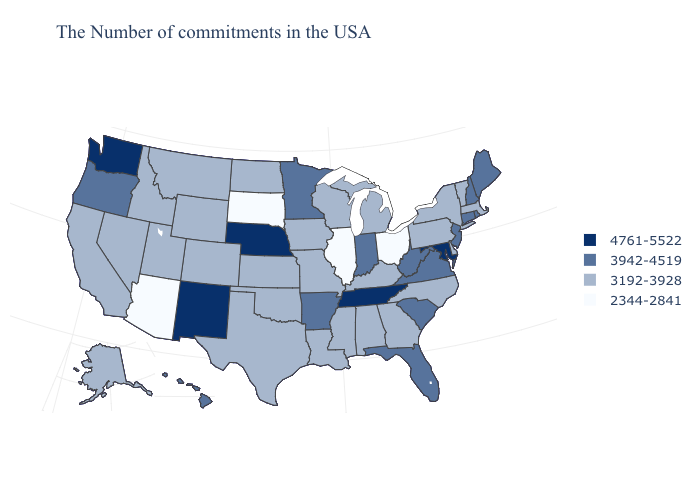What is the value of North Carolina?
Keep it brief. 3192-3928. Name the states that have a value in the range 3942-4519?
Concise answer only. Maine, Rhode Island, New Hampshire, Connecticut, New Jersey, Virginia, South Carolina, West Virginia, Florida, Indiana, Arkansas, Minnesota, Oregon, Hawaii. Does Wisconsin have the lowest value in the MidWest?
Keep it brief. No. What is the highest value in states that border Washington?
Short answer required. 3942-4519. Does Connecticut have the lowest value in the Northeast?
Keep it brief. No. What is the value of Kentucky?
Write a very short answer. 3192-3928. Name the states that have a value in the range 2344-2841?
Short answer required. Ohio, Illinois, South Dakota, Arizona. Among the states that border New York , does Pennsylvania have the highest value?
Concise answer only. No. What is the highest value in the South ?
Keep it brief. 4761-5522. What is the highest value in states that border Arizona?
Answer briefly. 4761-5522. Name the states that have a value in the range 3192-3928?
Short answer required. Massachusetts, Vermont, New York, Delaware, Pennsylvania, North Carolina, Georgia, Michigan, Kentucky, Alabama, Wisconsin, Mississippi, Louisiana, Missouri, Iowa, Kansas, Oklahoma, Texas, North Dakota, Wyoming, Colorado, Utah, Montana, Idaho, Nevada, California, Alaska. What is the highest value in the USA?
Write a very short answer. 4761-5522. Does Washington have the highest value in the West?
Short answer required. Yes. How many symbols are there in the legend?
Write a very short answer. 4. What is the highest value in states that border Kansas?
Answer briefly. 4761-5522. 